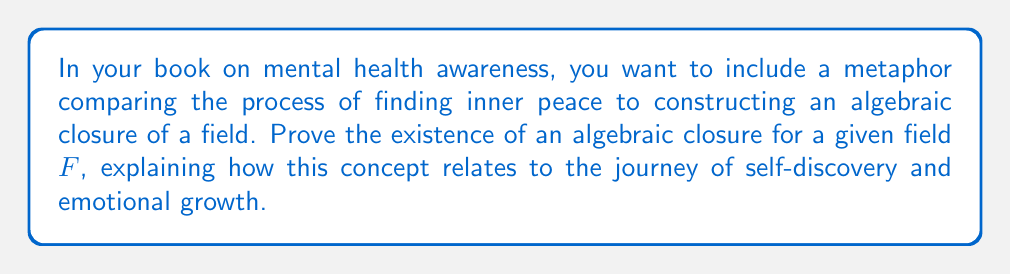Solve this math problem. Let's approach this proof step-by-step, drawing parallels to the mental health journey:

1) Define an algebraic closure:
   An algebraic closure of a field $F$ is an algebraic extension $\overline{F}$ of $F$ that is algebraically closed.

2) Start with the given field $F$ (representing one's initial state of mind).

3) Construct a sequence of field extensions:
   $F = F_0 \subset F_1 \subset F_2 \subset \cdots$
   where each $F_{i+1}$ is obtained by adjoining to $F_i$ the roots of all polynomials in $F_i[X]$ (This represents continuous personal growth and self-improvement).

4) Define $\overline{F} = \bigcup_{i=0}^{\infty} F_i$ (The union of all these experiences and growth stages).

5) Prove $\overline{F}$ is a field:
   - Closure under addition and multiplication follows from the field properties of each $F_i$.
   - The existence of additive and multiplicative inverses is guaranteed as they exist in some $F_j$ for large enough $j$.

6) Prove $\overline{F}$ is algebraically closed:
   Let $f(X) \in \overline{F}[X]$. Then $f(X) \in F_n[X]$ for some $n$. By construction, all roots of $f(X)$ are in $F_{n+1} \subset \overline{F}$.

7) Prove $\overline{F}$ is algebraic over $F$:
   Every element of $\overline{F}$ is in some $F_i$, which is algebraic over $F$ by construction.

This process mirrors the journey of self-discovery and emotional growth. Just as we build upon our experiences and learnings to reach a state of inner peace (algebraic closure), we construct increasingly complete extensions of our initial state until we reach a point where all our emotional "equations" have "solutions" within our developed mindset.
Answer: $\overline{F} = \bigcup_{i=0}^{\infty} F_i$, where each $F_{i+1}$ contains roots of all polynomials in $F_i[X]$. 